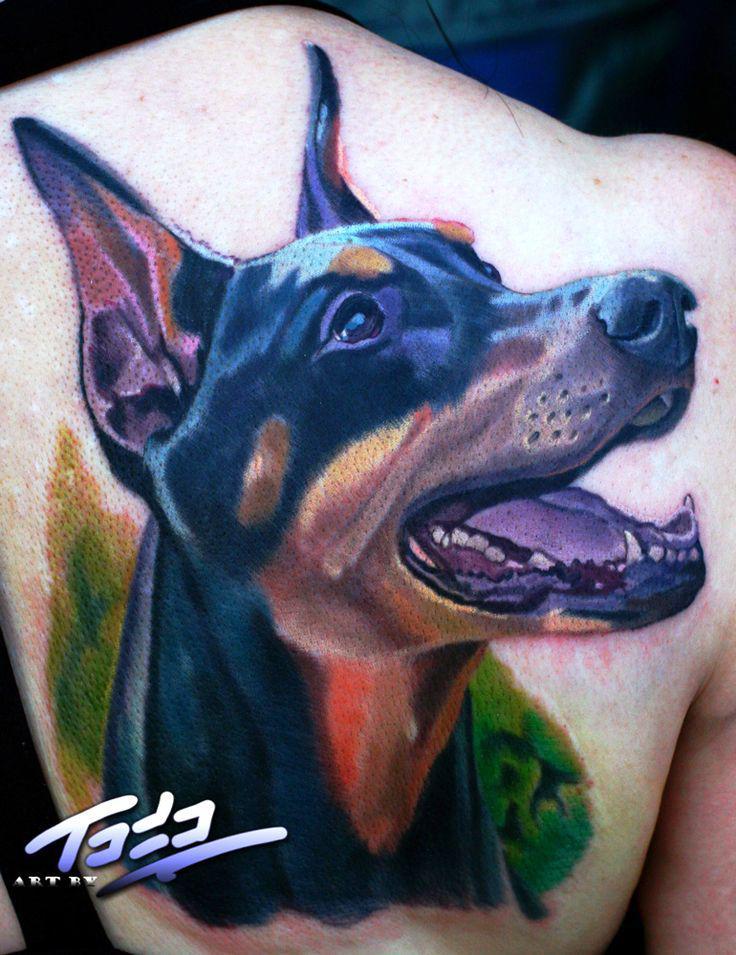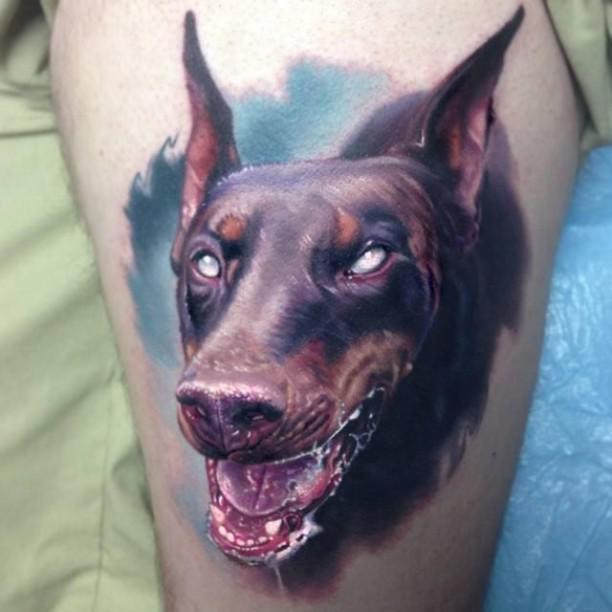The first image is the image on the left, the second image is the image on the right. Analyze the images presented: Is the assertion "In both drawings the doberman's mouth is open." valid? Answer yes or no. Yes. The first image is the image on the left, the second image is the image on the right. For the images shown, is this caption "The left and right image contains the same number of dog head tattoos." true? Answer yes or no. Yes. 